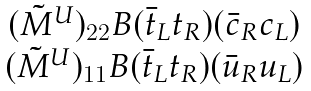<formula> <loc_0><loc_0><loc_500><loc_500>\begin{array} { c } ( { \tilde { M } } ^ { U } ) _ { 2 2 } B ( { \bar { t } } _ { L } t _ { R } ) ( { \bar { c } } _ { R } c _ { L } ) \\ ( { \tilde { M } } ^ { U } ) _ { 1 1 } B ( { \bar { t } } _ { L } t _ { R } ) ( { \bar { u } } _ { R } u _ { L } ) \end{array}</formula> 